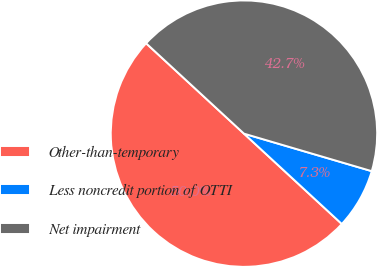<chart> <loc_0><loc_0><loc_500><loc_500><pie_chart><fcel>Other-than-temporary<fcel>Less noncredit portion of OTTI<fcel>Net impairment<nl><fcel>50.0%<fcel>7.32%<fcel>42.68%<nl></chart> 